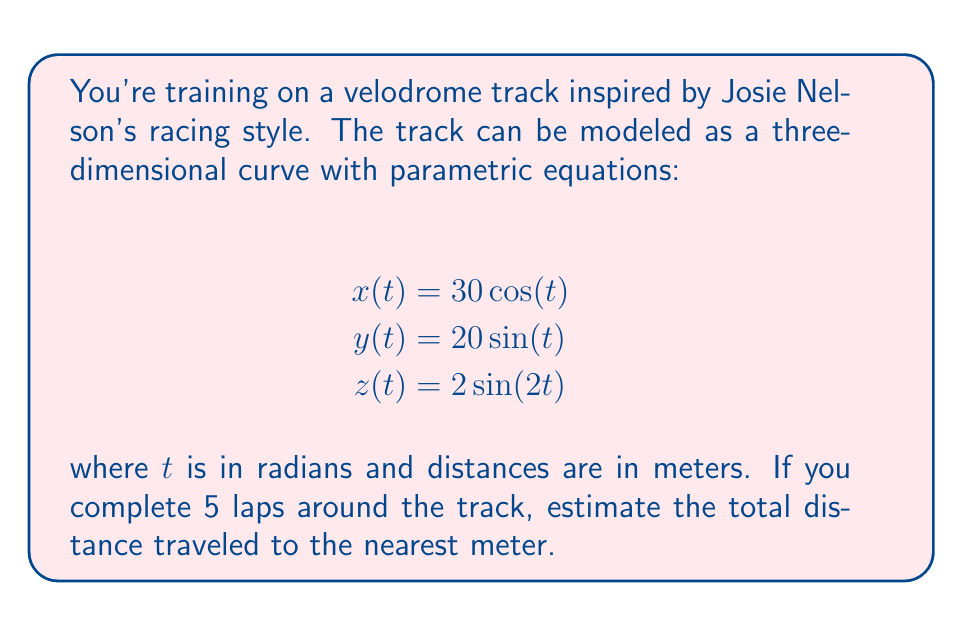What is the answer to this math problem? To solve this problem, we'll follow these steps:

1) The distance traveled along a parametric curve is given by the arc length formula:

   $$L = \int_{a}^{b} \sqrt{\left(\frac{dx}{dt}\right)^2 + \left(\frac{dy}{dt}\right)^2 + \left(\frac{dz}{dt}\right)^2} dt$$

2) First, let's find the derivatives:
   $$\frac{dx}{dt} = -30\sin(t)$$
   $$\frac{dy}{dt} = 20\cos(t)$$
   $$\frac{dz}{dt} = 4\cos(2t)$$

3) Now, let's substitute these into the integrand:

   $$\sqrt{\left(\frac{dx}{dt}\right)^2 + \left(\frac{dy}{dt}\right)^2 + \left(\frac{dz}{dt}\right)^2} = \sqrt{900\sin^2(t) + 400\cos^2(t) + 16\cos^2(2t)}$$

4) Simplify using the identity $\cos^2(2t) = \cos^2(t) - \sin^2(t)$:

   $$\sqrt{900\sin^2(t) + 400\cos^2(t) + 16(\cos^2(t) - \sin^2(t))}$$
   $$= \sqrt{884\sin^2(t) + 416\cos^2(t)}$$

5) This doesn't simplify further, so we need to evaluate the integral numerically. One lap is completed when $t$ goes from 0 to $2\pi$. For 5 laps, we integrate from 0 to $10\pi$.

6) Using a numerical integration method (like Simpson's rule or a computer algebra system), we get:

   $$L \approx 157.3$$

7) For 5 laps, we multiply this by 5:

   $$5L \approx 5 * 157.3 = 786.5$$

8) Rounding to the nearest meter gives us 787 meters.
Answer: The estimated total distance traveled for 5 laps is 787 meters. 